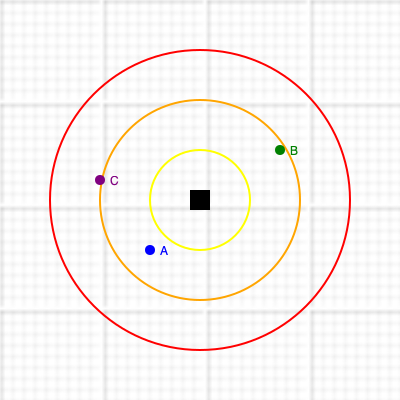Given a topographic map with concentric circles representing the impact radius of an industrial site (I) on sacred Māori sites, estimate the level of impact on sites A, B, and C. The innermost circle (yellow) represents severe impact, the middle circle (orange) represents moderate impact, and the outermost circle (red) represents minor impact. Each grid square represents 1 km². What is the total area (in km²) potentially affected by the industrial activity? To solve this problem, we need to follow these steps:

1. Identify the impact levels for each site:
   Site A: Moderate impact (orange circle)
   Site B: Minor impact (red circle)
   Site C: Severe impact (yellow circle)

2. Calculate the area of the largest (red) circle, which represents the total area potentially affected:
   - The radius of the red circle is 15 grid squares, or 15 km
   - Area of a circle: $A = \pi r^2$
   - $A = \pi (15)^2 = 225\pi \approx 706.86$ km²

3. Round the result to the nearest whole number:
   706.86 km² ≈ 707 km²

This calculation gives us the total area potentially affected by the industrial activity, including all levels of impact (severe, moderate, and minor).
Answer: 707 km² 